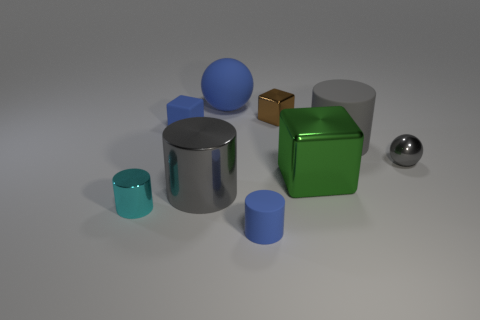How would you describe the arrangement of the objects? The objects are arranged in a somewhat haphazard manner, spread out across the surface with no apparent pattern or organization, giving the composition a casual, random appearance. 